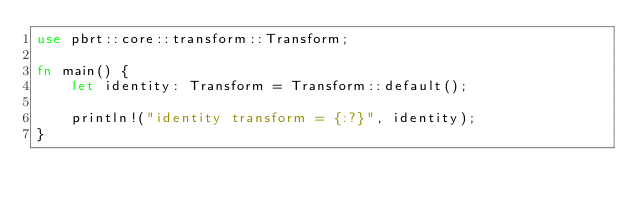Convert code to text. <code><loc_0><loc_0><loc_500><loc_500><_Rust_>use pbrt::core::transform::Transform;

fn main() {
    let identity: Transform = Transform::default();

    println!("identity transform = {:?}", identity);
}
</code> 